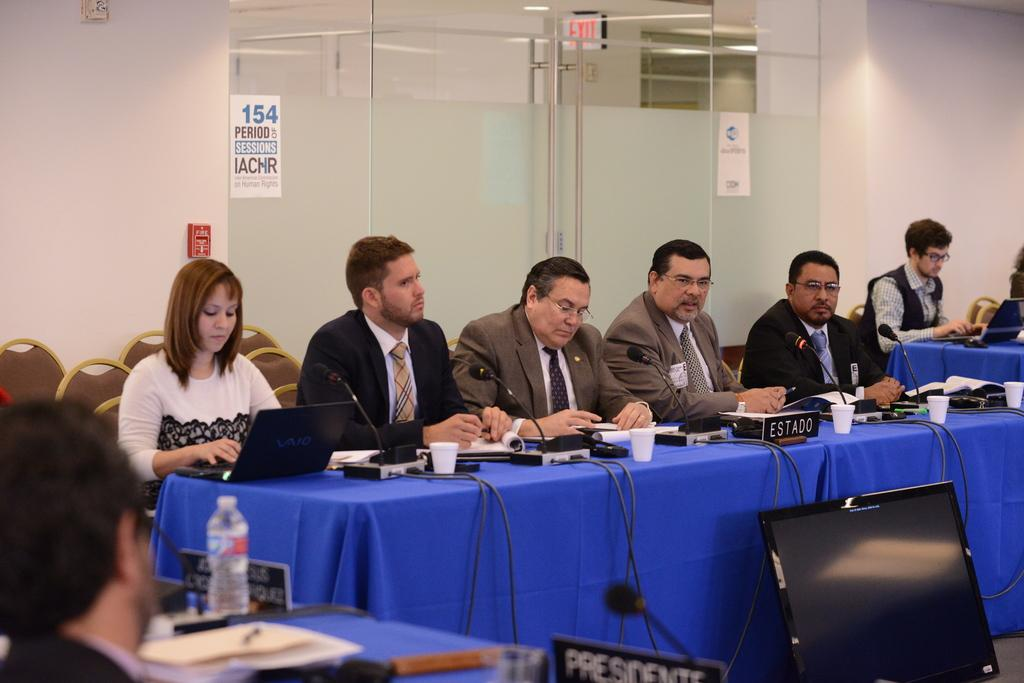Provide a one-sentence caption for the provided image. A conference is occurring in a room with a sign on the door that has number 154. 